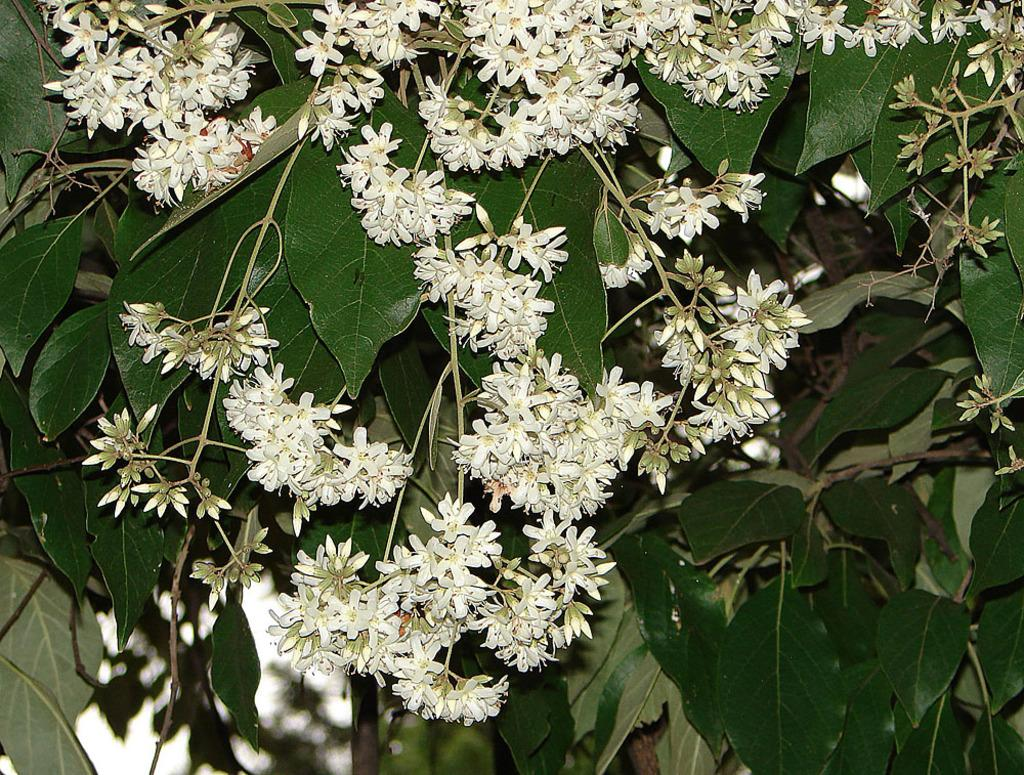What can be seen in the image that resembles plant life? There are branches in the image. What features can be observed on the branches? The branches have leaves and flowers. Can you tell me how deep the river is in the image? There is no river present in the image; it features branches with leaves and flowers. What type of friction can be observed between the branches and bushes in the image? There are no bushes present in the image, only branches with leaves and flowers. 